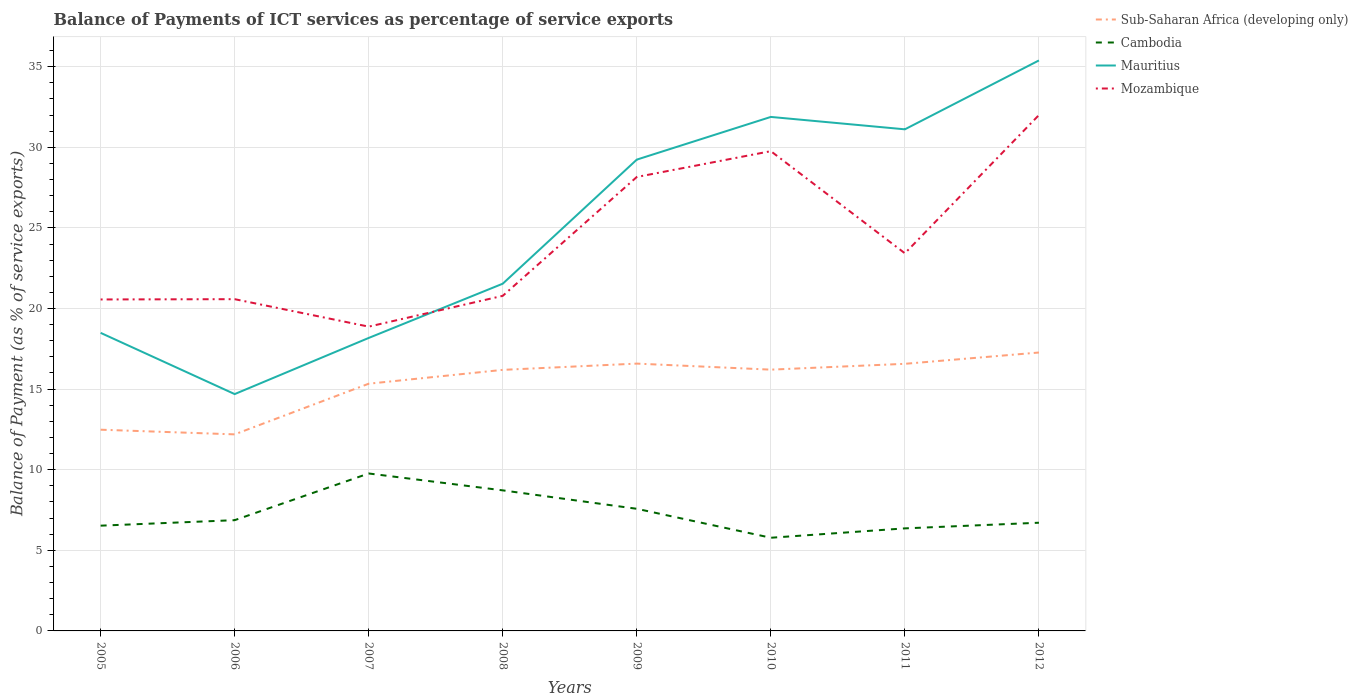How many different coloured lines are there?
Provide a succinct answer. 4. Across all years, what is the maximum balance of payments of ICT services in Mauritius?
Your answer should be compact. 14.69. In which year was the balance of payments of ICT services in Mauritius maximum?
Ensure brevity in your answer.  2006. What is the total balance of payments of ICT services in Cambodia in the graph?
Provide a short and direct response. -0.93. What is the difference between the highest and the second highest balance of payments of ICT services in Sub-Saharan Africa (developing only)?
Keep it short and to the point. 5.08. What is the difference between the highest and the lowest balance of payments of ICT services in Mauritius?
Your answer should be compact. 4. Is the balance of payments of ICT services in Cambodia strictly greater than the balance of payments of ICT services in Sub-Saharan Africa (developing only) over the years?
Your answer should be very brief. Yes. How many years are there in the graph?
Your response must be concise. 8. What is the difference between two consecutive major ticks on the Y-axis?
Your answer should be compact. 5. Are the values on the major ticks of Y-axis written in scientific E-notation?
Your answer should be very brief. No. Does the graph contain any zero values?
Your response must be concise. No. Does the graph contain grids?
Your response must be concise. Yes. How many legend labels are there?
Your response must be concise. 4. What is the title of the graph?
Provide a short and direct response. Balance of Payments of ICT services as percentage of service exports. What is the label or title of the Y-axis?
Give a very brief answer. Balance of Payment (as % of service exports). What is the Balance of Payment (as % of service exports) of Sub-Saharan Africa (developing only) in 2005?
Keep it short and to the point. 12.48. What is the Balance of Payment (as % of service exports) in Cambodia in 2005?
Keep it short and to the point. 6.53. What is the Balance of Payment (as % of service exports) in Mauritius in 2005?
Your answer should be compact. 18.49. What is the Balance of Payment (as % of service exports) in Mozambique in 2005?
Offer a terse response. 20.56. What is the Balance of Payment (as % of service exports) of Sub-Saharan Africa (developing only) in 2006?
Keep it short and to the point. 12.19. What is the Balance of Payment (as % of service exports) of Cambodia in 2006?
Give a very brief answer. 6.87. What is the Balance of Payment (as % of service exports) in Mauritius in 2006?
Ensure brevity in your answer.  14.69. What is the Balance of Payment (as % of service exports) in Mozambique in 2006?
Provide a succinct answer. 20.58. What is the Balance of Payment (as % of service exports) in Sub-Saharan Africa (developing only) in 2007?
Your answer should be very brief. 15.34. What is the Balance of Payment (as % of service exports) of Cambodia in 2007?
Ensure brevity in your answer.  9.77. What is the Balance of Payment (as % of service exports) of Mauritius in 2007?
Offer a very short reply. 18.17. What is the Balance of Payment (as % of service exports) in Mozambique in 2007?
Offer a very short reply. 18.88. What is the Balance of Payment (as % of service exports) in Sub-Saharan Africa (developing only) in 2008?
Give a very brief answer. 16.19. What is the Balance of Payment (as % of service exports) in Cambodia in 2008?
Ensure brevity in your answer.  8.72. What is the Balance of Payment (as % of service exports) in Mauritius in 2008?
Ensure brevity in your answer.  21.54. What is the Balance of Payment (as % of service exports) of Mozambique in 2008?
Offer a very short reply. 20.79. What is the Balance of Payment (as % of service exports) of Sub-Saharan Africa (developing only) in 2009?
Your response must be concise. 16.58. What is the Balance of Payment (as % of service exports) in Cambodia in 2009?
Give a very brief answer. 7.58. What is the Balance of Payment (as % of service exports) in Mauritius in 2009?
Ensure brevity in your answer.  29.24. What is the Balance of Payment (as % of service exports) of Mozambique in 2009?
Give a very brief answer. 28.16. What is the Balance of Payment (as % of service exports) in Sub-Saharan Africa (developing only) in 2010?
Your response must be concise. 16.21. What is the Balance of Payment (as % of service exports) of Cambodia in 2010?
Give a very brief answer. 5.78. What is the Balance of Payment (as % of service exports) in Mauritius in 2010?
Your answer should be compact. 31.88. What is the Balance of Payment (as % of service exports) in Mozambique in 2010?
Give a very brief answer. 29.76. What is the Balance of Payment (as % of service exports) of Sub-Saharan Africa (developing only) in 2011?
Offer a terse response. 16.57. What is the Balance of Payment (as % of service exports) of Cambodia in 2011?
Ensure brevity in your answer.  6.36. What is the Balance of Payment (as % of service exports) in Mauritius in 2011?
Make the answer very short. 31.12. What is the Balance of Payment (as % of service exports) of Mozambique in 2011?
Offer a very short reply. 23.43. What is the Balance of Payment (as % of service exports) in Sub-Saharan Africa (developing only) in 2012?
Ensure brevity in your answer.  17.27. What is the Balance of Payment (as % of service exports) in Cambodia in 2012?
Keep it short and to the point. 6.71. What is the Balance of Payment (as % of service exports) in Mauritius in 2012?
Keep it short and to the point. 35.39. What is the Balance of Payment (as % of service exports) in Mozambique in 2012?
Ensure brevity in your answer.  32. Across all years, what is the maximum Balance of Payment (as % of service exports) of Sub-Saharan Africa (developing only)?
Keep it short and to the point. 17.27. Across all years, what is the maximum Balance of Payment (as % of service exports) of Cambodia?
Give a very brief answer. 9.77. Across all years, what is the maximum Balance of Payment (as % of service exports) of Mauritius?
Offer a very short reply. 35.39. Across all years, what is the maximum Balance of Payment (as % of service exports) in Mozambique?
Give a very brief answer. 32. Across all years, what is the minimum Balance of Payment (as % of service exports) of Sub-Saharan Africa (developing only)?
Your answer should be very brief. 12.19. Across all years, what is the minimum Balance of Payment (as % of service exports) of Cambodia?
Your answer should be very brief. 5.78. Across all years, what is the minimum Balance of Payment (as % of service exports) in Mauritius?
Keep it short and to the point. 14.69. Across all years, what is the minimum Balance of Payment (as % of service exports) in Mozambique?
Offer a terse response. 18.88. What is the total Balance of Payment (as % of service exports) in Sub-Saharan Africa (developing only) in the graph?
Provide a short and direct response. 122.83. What is the total Balance of Payment (as % of service exports) of Cambodia in the graph?
Your answer should be compact. 58.31. What is the total Balance of Payment (as % of service exports) in Mauritius in the graph?
Ensure brevity in your answer.  200.52. What is the total Balance of Payment (as % of service exports) of Mozambique in the graph?
Your answer should be compact. 194.15. What is the difference between the Balance of Payment (as % of service exports) of Sub-Saharan Africa (developing only) in 2005 and that in 2006?
Ensure brevity in your answer.  0.29. What is the difference between the Balance of Payment (as % of service exports) of Cambodia in 2005 and that in 2006?
Give a very brief answer. -0.34. What is the difference between the Balance of Payment (as % of service exports) in Mauritius in 2005 and that in 2006?
Provide a succinct answer. 3.8. What is the difference between the Balance of Payment (as % of service exports) in Mozambique in 2005 and that in 2006?
Make the answer very short. -0.02. What is the difference between the Balance of Payment (as % of service exports) of Sub-Saharan Africa (developing only) in 2005 and that in 2007?
Give a very brief answer. -2.85. What is the difference between the Balance of Payment (as % of service exports) in Cambodia in 2005 and that in 2007?
Ensure brevity in your answer.  -3.24. What is the difference between the Balance of Payment (as % of service exports) in Mauritius in 2005 and that in 2007?
Offer a terse response. 0.32. What is the difference between the Balance of Payment (as % of service exports) of Mozambique in 2005 and that in 2007?
Your response must be concise. 1.69. What is the difference between the Balance of Payment (as % of service exports) in Sub-Saharan Africa (developing only) in 2005 and that in 2008?
Ensure brevity in your answer.  -3.71. What is the difference between the Balance of Payment (as % of service exports) of Cambodia in 2005 and that in 2008?
Your response must be concise. -2.19. What is the difference between the Balance of Payment (as % of service exports) in Mauritius in 2005 and that in 2008?
Give a very brief answer. -3.05. What is the difference between the Balance of Payment (as % of service exports) of Mozambique in 2005 and that in 2008?
Provide a short and direct response. -0.22. What is the difference between the Balance of Payment (as % of service exports) in Cambodia in 2005 and that in 2009?
Keep it short and to the point. -1.05. What is the difference between the Balance of Payment (as % of service exports) of Mauritius in 2005 and that in 2009?
Offer a very short reply. -10.75. What is the difference between the Balance of Payment (as % of service exports) in Mozambique in 2005 and that in 2009?
Provide a succinct answer. -7.6. What is the difference between the Balance of Payment (as % of service exports) in Sub-Saharan Africa (developing only) in 2005 and that in 2010?
Provide a succinct answer. -3.73. What is the difference between the Balance of Payment (as % of service exports) in Cambodia in 2005 and that in 2010?
Provide a short and direct response. 0.75. What is the difference between the Balance of Payment (as % of service exports) in Mauritius in 2005 and that in 2010?
Keep it short and to the point. -13.39. What is the difference between the Balance of Payment (as % of service exports) of Mozambique in 2005 and that in 2010?
Your answer should be very brief. -9.2. What is the difference between the Balance of Payment (as % of service exports) of Sub-Saharan Africa (developing only) in 2005 and that in 2011?
Make the answer very short. -4.09. What is the difference between the Balance of Payment (as % of service exports) in Cambodia in 2005 and that in 2011?
Provide a succinct answer. 0.17. What is the difference between the Balance of Payment (as % of service exports) in Mauritius in 2005 and that in 2011?
Keep it short and to the point. -12.63. What is the difference between the Balance of Payment (as % of service exports) of Mozambique in 2005 and that in 2011?
Ensure brevity in your answer.  -2.86. What is the difference between the Balance of Payment (as % of service exports) of Sub-Saharan Africa (developing only) in 2005 and that in 2012?
Your response must be concise. -4.79. What is the difference between the Balance of Payment (as % of service exports) of Cambodia in 2005 and that in 2012?
Your answer should be compact. -0.18. What is the difference between the Balance of Payment (as % of service exports) in Mauritius in 2005 and that in 2012?
Offer a very short reply. -16.9. What is the difference between the Balance of Payment (as % of service exports) in Mozambique in 2005 and that in 2012?
Provide a short and direct response. -11.44. What is the difference between the Balance of Payment (as % of service exports) of Sub-Saharan Africa (developing only) in 2006 and that in 2007?
Provide a succinct answer. -3.14. What is the difference between the Balance of Payment (as % of service exports) of Cambodia in 2006 and that in 2007?
Your response must be concise. -2.9. What is the difference between the Balance of Payment (as % of service exports) in Mauritius in 2006 and that in 2007?
Your answer should be very brief. -3.48. What is the difference between the Balance of Payment (as % of service exports) of Mozambique in 2006 and that in 2007?
Your answer should be compact. 1.7. What is the difference between the Balance of Payment (as % of service exports) of Sub-Saharan Africa (developing only) in 2006 and that in 2008?
Your answer should be compact. -4. What is the difference between the Balance of Payment (as % of service exports) of Cambodia in 2006 and that in 2008?
Keep it short and to the point. -1.85. What is the difference between the Balance of Payment (as % of service exports) in Mauritius in 2006 and that in 2008?
Your response must be concise. -6.85. What is the difference between the Balance of Payment (as % of service exports) of Mozambique in 2006 and that in 2008?
Your answer should be compact. -0.21. What is the difference between the Balance of Payment (as % of service exports) in Sub-Saharan Africa (developing only) in 2006 and that in 2009?
Give a very brief answer. -4.39. What is the difference between the Balance of Payment (as % of service exports) in Cambodia in 2006 and that in 2009?
Your answer should be very brief. -0.71. What is the difference between the Balance of Payment (as % of service exports) of Mauritius in 2006 and that in 2009?
Offer a very short reply. -14.54. What is the difference between the Balance of Payment (as % of service exports) of Mozambique in 2006 and that in 2009?
Your answer should be very brief. -7.58. What is the difference between the Balance of Payment (as % of service exports) of Sub-Saharan Africa (developing only) in 2006 and that in 2010?
Your response must be concise. -4.01. What is the difference between the Balance of Payment (as % of service exports) of Cambodia in 2006 and that in 2010?
Provide a succinct answer. 1.09. What is the difference between the Balance of Payment (as % of service exports) of Mauritius in 2006 and that in 2010?
Provide a short and direct response. -17.19. What is the difference between the Balance of Payment (as % of service exports) of Mozambique in 2006 and that in 2010?
Offer a very short reply. -9.18. What is the difference between the Balance of Payment (as % of service exports) of Sub-Saharan Africa (developing only) in 2006 and that in 2011?
Your answer should be very brief. -4.38. What is the difference between the Balance of Payment (as % of service exports) of Cambodia in 2006 and that in 2011?
Give a very brief answer. 0.51. What is the difference between the Balance of Payment (as % of service exports) in Mauritius in 2006 and that in 2011?
Keep it short and to the point. -16.42. What is the difference between the Balance of Payment (as % of service exports) in Mozambique in 2006 and that in 2011?
Your response must be concise. -2.85. What is the difference between the Balance of Payment (as % of service exports) in Sub-Saharan Africa (developing only) in 2006 and that in 2012?
Your answer should be very brief. -5.08. What is the difference between the Balance of Payment (as % of service exports) in Cambodia in 2006 and that in 2012?
Your response must be concise. 0.16. What is the difference between the Balance of Payment (as % of service exports) in Mauritius in 2006 and that in 2012?
Your response must be concise. -20.7. What is the difference between the Balance of Payment (as % of service exports) in Mozambique in 2006 and that in 2012?
Your answer should be compact. -11.42. What is the difference between the Balance of Payment (as % of service exports) of Sub-Saharan Africa (developing only) in 2007 and that in 2008?
Keep it short and to the point. -0.86. What is the difference between the Balance of Payment (as % of service exports) of Cambodia in 2007 and that in 2008?
Provide a short and direct response. 1.05. What is the difference between the Balance of Payment (as % of service exports) of Mauritius in 2007 and that in 2008?
Your answer should be compact. -3.37. What is the difference between the Balance of Payment (as % of service exports) of Mozambique in 2007 and that in 2008?
Give a very brief answer. -1.91. What is the difference between the Balance of Payment (as % of service exports) of Sub-Saharan Africa (developing only) in 2007 and that in 2009?
Your answer should be very brief. -1.25. What is the difference between the Balance of Payment (as % of service exports) in Cambodia in 2007 and that in 2009?
Your response must be concise. 2.19. What is the difference between the Balance of Payment (as % of service exports) of Mauritius in 2007 and that in 2009?
Keep it short and to the point. -11.06. What is the difference between the Balance of Payment (as % of service exports) of Mozambique in 2007 and that in 2009?
Your answer should be compact. -9.28. What is the difference between the Balance of Payment (as % of service exports) in Sub-Saharan Africa (developing only) in 2007 and that in 2010?
Offer a very short reply. -0.87. What is the difference between the Balance of Payment (as % of service exports) of Cambodia in 2007 and that in 2010?
Give a very brief answer. 3.99. What is the difference between the Balance of Payment (as % of service exports) of Mauritius in 2007 and that in 2010?
Make the answer very short. -13.71. What is the difference between the Balance of Payment (as % of service exports) in Mozambique in 2007 and that in 2010?
Provide a succinct answer. -10.88. What is the difference between the Balance of Payment (as % of service exports) in Sub-Saharan Africa (developing only) in 2007 and that in 2011?
Provide a short and direct response. -1.23. What is the difference between the Balance of Payment (as % of service exports) in Cambodia in 2007 and that in 2011?
Your answer should be very brief. 3.41. What is the difference between the Balance of Payment (as % of service exports) of Mauritius in 2007 and that in 2011?
Offer a very short reply. -12.94. What is the difference between the Balance of Payment (as % of service exports) in Mozambique in 2007 and that in 2011?
Keep it short and to the point. -4.55. What is the difference between the Balance of Payment (as % of service exports) of Sub-Saharan Africa (developing only) in 2007 and that in 2012?
Your response must be concise. -1.93. What is the difference between the Balance of Payment (as % of service exports) in Cambodia in 2007 and that in 2012?
Your answer should be compact. 3.06. What is the difference between the Balance of Payment (as % of service exports) in Mauritius in 2007 and that in 2012?
Give a very brief answer. -17.21. What is the difference between the Balance of Payment (as % of service exports) in Mozambique in 2007 and that in 2012?
Your answer should be compact. -13.13. What is the difference between the Balance of Payment (as % of service exports) of Sub-Saharan Africa (developing only) in 2008 and that in 2009?
Give a very brief answer. -0.39. What is the difference between the Balance of Payment (as % of service exports) of Cambodia in 2008 and that in 2009?
Ensure brevity in your answer.  1.14. What is the difference between the Balance of Payment (as % of service exports) of Mauritius in 2008 and that in 2009?
Make the answer very short. -7.7. What is the difference between the Balance of Payment (as % of service exports) of Mozambique in 2008 and that in 2009?
Make the answer very short. -7.37. What is the difference between the Balance of Payment (as % of service exports) of Sub-Saharan Africa (developing only) in 2008 and that in 2010?
Ensure brevity in your answer.  -0.01. What is the difference between the Balance of Payment (as % of service exports) of Cambodia in 2008 and that in 2010?
Keep it short and to the point. 2.94. What is the difference between the Balance of Payment (as % of service exports) of Mauritius in 2008 and that in 2010?
Offer a terse response. -10.34. What is the difference between the Balance of Payment (as % of service exports) in Mozambique in 2008 and that in 2010?
Make the answer very short. -8.97. What is the difference between the Balance of Payment (as % of service exports) in Sub-Saharan Africa (developing only) in 2008 and that in 2011?
Your answer should be compact. -0.38. What is the difference between the Balance of Payment (as % of service exports) in Cambodia in 2008 and that in 2011?
Offer a very short reply. 2.36. What is the difference between the Balance of Payment (as % of service exports) of Mauritius in 2008 and that in 2011?
Ensure brevity in your answer.  -9.58. What is the difference between the Balance of Payment (as % of service exports) in Mozambique in 2008 and that in 2011?
Keep it short and to the point. -2.64. What is the difference between the Balance of Payment (as % of service exports) of Sub-Saharan Africa (developing only) in 2008 and that in 2012?
Make the answer very short. -1.08. What is the difference between the Balance of Payment (as % of service exports) of Cambodia in 2008 and that in 2012?
Your answer should be very brief. 2.01. What is the difference between the Balance of Payment (as % of service exports) in Mauritius in 2008 and that in 2012?
Make the answer very short. -13.85. What is the difference between the Balance of Payment (as % of service exports) of Mozambique in 2008 and that in 2012?
Offer a very short reply. -11.21. What is the difference between the Balance of Payment (as % of service exports) of Cambodia in 2009 and that in 2010?
Offer a terse response. 1.8. What is the difference between the Balance of Payment (as % of service exports) of Mauritius in 2009 and that in 2010?
Ensure brevity in your answer.  -2.65. What is the difference between the Balance of Payment (as % of service exports) in Mozambique in 2009 and that in 2010?
Keep it short and to the point. -1.6. What is the difference between the Balance of Payment (as % of service exports) of Sub-Saharan Africa (developing only) in 2009 and that in 2011?
Provide a short and direct response. 0.01. What is the difference between the Balance of Payment (as % of service exports) of Cambodia in 2009 and that in 2011?
Your response must be concise. 1.21. What is the difference between the Balance of Payment (as % of service exports) in Mauritius in 2009 and that in 2011?
Provide a short and direct response. -1.88. What is the difference between the Balance of Payment (as % of service exports) of Mozambique in 2009 and that in 2011?
Provide a short and direct response. 4.73. What is the difference between the Balance of Payment (as % of service exports) in Sub-Saharan Africa (developing only) in 2009 and that in 2012?
Offer a terse response. -0.69. What is the difference between the Balance of Payment (as % of service exports) of Cambodia in 2009 and that in 2012?
Offer a terse response. 0.86. What is the difference between the Balance of Payment (as % of service exports) of Mauritius in 2009 and that in 2012?
Make the answer very short. -6.15. What is the difference between the Balance of Payment (as % of service exports) of Mozambique in 2009 and that in 2012?
Provide a short and direct response. -3.84. What is the difference between the Balance of Payment (as % of service exports) of Sub-Saharan Africa (developing only) in 2010 and that in 2011?
Provide a succinct answer. -0.36. What is the difference between the Balance of Payment (as % of service exports) of Cambodia in 2010 and that in 2011?
Provide a succinct answer. -0.58. What is the difference between the Balance of Payment (as % of service exports) in Mauritius in 2010 and that in 2011?
Provide a succinct answer. 0.77. What is the difference between the Balance of Payment (as % of service exports) in Mozambique in 2010 and that in 2011?
Make the answer very short. 6.34. What is the difference between the Balance of Payment (as % of service exports) of Sub-Saharan Africa (developing only) in 2010 and that in 2012?
Ensure brevity in your answer.  -1.06. What is the difference between the Balance of Payment (as % of service exports) of Cambodia in 2010 and that in 2012?
Your response must be concise. -0.93. What is the difference between the Balance of Payment (as % of service exports) in Mauritius in 2010 and that in 2012?
Your answer should be very brief. -3.5. What is the difference between the Balance of Payment (as % of service exports) in Mozambique in 2010 and that in 2012?
Your answer should be very brief. -2.24. What is the difference between the Balance of Payment (as % of service exports) of Sub-Saharan Africa (developing only) in 2011 and that in 2012?
Offer a terse response. -0.7. What is the difference between the Balance of Payment (as % of service exports) in Cambodia in 2011 and that in 2012?
Provide a short and direct response. -0.35. What is the difference between the Balance of Payment (as % of service exports) of Mauritius in 2011 and that in 2012?
Give a very brief answer. -4.27. What is the difference between the Balance of Payment (as % of service exports) in Mozambique in 2011 and that in 2012?
Your answer should be very brief. -8.58. What is the difference between the Balance of Payment (as % of service exports) of Sub-Saharan Africa (developing only) in 2005 and the Balance of Payment (as % of service exports) of Cambodia in 2006?
Give a very brief answer. 5.61. What is the difference between the Balance of Payment (as % of service exports) in Sub-Saharan Africa (developing only) in 2005 and the Balance of Payment (as % of service exports) in Mauritius in 2006?
Keep it short and to the point. -2.21. What is the difference between the Balance of Payment (as % of service exports) of Sub-Saharan Africa (developing only) in 2005 and the Balance of Payment (as % of service exports) of Mozambique in 2006?
Keep it short and to the point. -8.1. What is the difference between the Balance of Payment (as % of service exports) in Cambodia in 2005 and the Balance of Payment (as % of service exports) in Mauritius in 2006?
Provide a short and direct response. -8.16. What is the difference between the Balance of Payment (as % of service exports) of Cambodia in 2005 and the Balance of Payment (as % of service exports) of Mozambique in 2006?
Keep it short and to the point. -14.05. What is the difference between the Balance of Payment (as % of service exports) of Mauritius in 2005 and the Balance of Payment (as % of service exports) of Mozambique in 2006?
Offer a very short reply. -2.09. What is the difference between the Balance of Payment (as % of service exports) in Sub-Saharan Africa (developing only) in 2005 and the Balance of Payment (as % of service exports) in Cambodia in 2007?
Your answer should be very brief. 2.72. What is the difference between the Balance of Payment (as % of service exports) in Sub-Saharan Africa (developing only) in 2005 and the Balance of Payment (as % of service exports) in Mauritius in 2007?
Your response must be concise. -5.69. What is the difference between the Balance of Payment (as % of service exports) of Sub-Saharan Africa (developing only) in 2005 and the Balance of Payment (as % of service exports) of Mozambique in 2007?
Your response must be concise. -6.39. What is the difference between the Balance of Payment (as % of service exports) of Cambodia in 2005 and the Balance of Payment (as % of service exports) of Mauritius in 2007?
Give a very brief answer. -11.64. What is the difference between the Balance of Payment (as % of service exports) of Cambodia in 2005 and the Balance of Payment (as % of service exports) of Mozambique in 2007?
Your response must be concise. -12.35. What is the difference between the Balance of Payment (as % of service exports) in Mauritius in 2005 and the Balance of Payment (as % of service exports) in Mozambique in 2007?
Your answer should be compact. -0.39. What is the difference between the Balance of Payment (as % of service exports) in Sub-Saharan Africa (developing only) in 2005 and the Balance of Payment (as % of service exports) in Cambodia in 2008?
Your answer should be compact. 3.76. What is the difference between the Balance of Payment (as % of service exports) of Sub-Saharan Africa (developing only) in 2005 and the Balance of Payment (as % of service exports) of Mauritius in 2008?
Ensure brevity in your answer.  -9.06. What is the difference between the Balance of Payment (as % of service exports) of Sub-Saharan Africa (developing only) in 2005 and the Balance of Payment (as % of service exports) of Mozambique in 2008?
Offer a very short reply. -8.3. What is the difference between the Balance of Payment (as % of service exports) in Cambodia in 2005 and the Balance of Payment (as % of service exports) in Mauritius in 2008?
Give a very brief answer. -15.01. What is the difference between the Balance of Payment (as % of service exports) of Cambodia in 2005 and the Balance of Payment (as % of service exports) of Mozambique in 2008?
Provide a short and direct response. -14.26. What is the difference between the Balance of Payment (as % of service exports) in Mauritius in 2005 and the Balance of Payment (as % of service exports) in Mozambique in 2008?
Your response must be concise. -2.3. What is the difference between the Balance of Payment (as % of service exports) of Sub-Saharan Africa (developing only) in 2005 and the Balance of Payment (as % of service exports) of Cambodia in 2009?
Ensure brevity in your answer.  4.91. What is the difference between the Balance of Payment (as % of service exports) in Sub-Saharan Africa (developing only) in 2005 and the Balance of Payment (as % of service exports) in Mauritius in 2009?
Offer a very short reply. -16.75. What is the difference between the Balance of Payment (as % of service exports) of Sub-Saharan Africa (developing only) in 2005 and the Balance of Payment (as % of service exports) of Mozambique in 2009?
Ensure brevity in your answer.  -15.68. What is the difference between the Balance of Payment (as % of service exports) in Cambodia in 2005 and the Balance of Payment (as % of service exports) in Mauritius in 2009?
Ensure brevity in your answer.  -22.71. What is the difference between the Balance of Payment (as % of service exports) in Cambodia in 2005 and the Balance of Payment (as % of service exports) in Mozambique in 2009?
Your response must be concise. -21.63. What is the difference between the Balance of Payment (as % of service exports) in Mauritius in 2005 and the Balance of Payment (as % of service exports) in Mozambique in 2009?
Your answer should be very brief. -9.67. What is the difference between the Balance of Payment (as % of service exports) of Sub-Saharan Africa (developing only) in 2005 and the Balance of Payment (as % of service exports) of Cambodia in 2010?
Your answer should be very brief. 6.7. What is the difference between the Balance of Payment (as % of service exports) of Sub-Saharan Africa (developing only) in 2005 and the Balance of Payment (as % of service exports) of Mauritius in 2010?
Offer a very short reply. -19.4. What is the difference between the Balance of Payment (as % of service exports) in Sub-Saharan Africa (developing only) in 2005 and the Balance of Payment (as % of service exports) in Mozambique in 2010?
Offer a very short reply. -17.28. What is the difference between the Balance of Payment (as % of service exports) of Cambodia in 2005 and the Balance of Payment (as % of service exports) of Mauritius in 2010?
Your answer should be compact. -25.36. What is the difference between the Balance of Payment (as % of service exports) in Cambodia in 2005 and the Balance of Payment (as % of service exports) in Mozambique in 2010?
Give a very brief answer. -23.23. What is the difference between the Balance of Payment (as % of service exports) of Mauritius in 2005 and the Balance of Payment (as % of service exports) of Mozambique in 2010?
Make the answer very short. -11.27. What is the difference between the Balance of Payment (as % of service exports) of Sub-Saharan Africa (developing only) in 2005 and the Balance of Payment (as % of service exports) of Cambodia in 2011?
Offer a terse response. 6.12. What is the difference between the Balance of Payment (as % of service exports) of Sub-Saharan Africa (developing only) in 2005 and the Balance of Payment (as % of service exports) of Mauritius in 2011?
Your answer should be very brief. -18.63. What is the difference between the Balance of Payment (as % of service exports) in Sub-Saharan Africa (developing only) in 2005 and the Balance of Payment (as % of service exports) in Mozambique in 2011?
Keep it short and to the point. -10.94. What is the difference between the Balance of Payment (as % of service exports) in Cambodia in 2005 and the Balance of Payment (as % of service exports) in Mauritius in 2011?
Your response must be concise. -24.59. What is the difference between the Balance of Payment (as % of service exports) of Cambodia in 2005 and the Balance of Payment (as % of service exports) of Mozambique in 2011?
Your response must be concise. -16.9. What is the difference between the Balance of Payment (as % of service exports) of Mauritius in 2005 and the Balance of Payment (as % of service exports) of Mozambique in 2011?
Keep it short and to the point. -4.94. What is the difference between the Balance of Payment (as % of service exports) of Sub-Saharan Africa (developing only) in 2005 and the Balance of Payment (as % of service exports) of Cambodia in 2012?
Provide a succinct answer. 5.77. What is the difference between the Balance of Payment (as % of service exports) of Sub-Saharan Africa (developing only) in 2005 and the Balance of Payment (as % of service exports) of Mauritius in 2012?
Make the answer very short. -22.91. What is the difference between the Balance of Payment (as % of service exports) of Sub-Saharan Africa (developing only) in 2005 and the Balance of Payment (as % of service exports) of Mozambique in 2012?
Make the answer very short. -19.52. What is the difference between the Balance of Payment (as % of service exports) of Cambodia in 2005 and the Balance of Payment (as % of service exports) of Mauritius in 2012?
Make the answer very short. -28.86. What is the difference between the Balance of Payment (as % of service exports) in Cambodia in 2005 and the Balance of Payment (as % of service exports) in Mozambique in 2012?
Provide a succinct answer. -25.47. What is the difference between the Balance of Payment (as % of service exports) in Mauritius in 2005 and the Balance of Payment (as % of service exports) in Mozambique in 2012?
Offer a terse response. -13.51. What is the difference between the Balance of Payment (as % of service exports) in Sub-Saharan Africa (developing only) in 2006 and the Balance of Payment (as % of service exports) in Cambodia in 2007?
Your answer should be very brief. 2.43. What is the difference between the Balance of Payment (as % of service exports) of Sub-Saharan Africa (developing only) in 2006 and the Balance of Payment (as % of service exports) of Mauritius in 2007?
Your answer should be compact. -5.98. What is the difference between the Balance of Payment (as % of service exports) in Sub-Saharan Africa (developing only) in 2006 and the Balance of Payment (as % of service exports) in Mozambique in 2007?
Provide a short and direct response. -6.68. What is the difference between the Balance of Payment (as % of service exports) of Cambodia in 2006 and the Balance of Payment (as % of service exports) of Mauritius in 2007?
Provide a short and direct response. -11.3. What is the difference between the Balance of Payment (as % of service exports) of Cambodia in 2006 and the Balance of Payment (as % of service exports) of Mozambique in 2007?
Your answer should be very brief. -12.01. What is the difference between the Balance of Payment (as % of service exports) of Mauritius in 2006 and the Balance of Payment (as % of service exports) of Mozambique in 2007?
Your answer should be very brief. -4.18. What is the difference between the Balance of Payment (as % of service exports) of Sub-Saharan Africa (developing only) in 2006 and the Balance of Payment (as % of service exports) of Cambodia in 2008?
Provide a succinct answer. 3.47. What is the difference between the Balance of Payment (as % of service exports) of Sub-Saharan Africa (developing only) in 2006 and the Balance of Payment (as % of service exports) of Mauritius in 2008?
Keep it short and to the point. -9.35. What is the difference between the Balance of Payment (as % of service exports) in Sub-Saharan Africa (developing only) in 2006 and the Balance of Payment (as % of service exports) in Mozambique in 2008?
Provide a short and direct response. -8.59. What is the difference between the Balance of Payment (as % of service exports) in Cambodia in 2006 and the Balance of Payment (as % of service exports) in Mauritius in 2008?
Offer a very short reply. -14.67. What is the difference between the Balance of Payment (as % of service exports) in Cambodia in 2006 and the Balance of Payment (as % of service exports) in Mozambique in 2008?
Provide a succinct answer. -13.92. What is the difference between the Balance of Payment (as % of service exports) of Mauritius in 2006 and the Balance of Payment (as % of service exports) of Mozambique in 2008?
Ensure brevity in your answer.  -6.1. What is the difference between the Balance of Payment (as % of service exports) of Sub-Saharan Africa (developing only) in 2006 and the Balance of Payment (as % of service exports) of Cambodia in 2009?
Make the answer very short. 4.62. What is the difference between the Balance of Payment (as % of service exports) of Sub-Saharan Africa (developing only) in 2006 and the Balance of Payment (as % of service exports) of Mauritius in 2009?
Ensure brevity in your answer.  -17.04. What is the difference between the Balance of Payment (as % of service exports) in Sub-Saharan Africa (developing only) in 2006 and the Balance of Payment (as % of service exports) in Mozambique in 2009?
Your answer should be compact. -15.97. What is the difference between the Balance of Payment (as % of service exports) in Cambodia in 2006 and the Balance of Payment (as % of service exports) in Mauritius in 2009?
Your answer should be very brief. -22.37. What is the difference between the Balance of Payment (as % of service exports) of Cambodia in 2006 and the Balance of Payment (as % of service exports) of Mozambique in 2009?
Provide a short and direct response. -21.29. What is the difference between the Balance of Payment (as % of service exports) of Mauritius in 2006 and the Balance of Payment (as % of service exports) of Mozambique in 2009?
Your answer should be very brief. -13.47. What is the difference between the Balance of Payment (as % of service exports) of Sub-Saharan Africa (developing only) in 2006 and the Balance of Payment (as % of service exports) of Cambodia in 2010?
Give a very brief answer. 6.41. What is the difference between the Balance of Payment (as % of service exports) of Sub-Saharan Africa (developing only) in 2006 and the Balance of Payment (as % of service exports) of Mauritius in 2010?
Your response must be concise. -19.69. What is the difference between the Balance of Payment (as % of service exports) of Sub-Saharan Africa (developing only) in 2006 and the Balance of Payment (as % of service exports) of Mozambique in 2010?
Make the answer very short. -17.57. What is the difference between the Balance of Payment (as % of service exports) of Cambodia in 2006 and the Balance of Payment (as % of service exports) of Mauritius in 2010?
Give a very brief answer. -25.01. What is the difference between the Balance of Payment (as % of service exports) in Cambodia in 2006 and the Balance of Payment (as % of service exports) in Mozambique in 2010?
Provide a short and direct response. -22.89. What is the difference between the Balance of Payment (as % of service exports) of Mauritius in 2006 and the Balance of Payment (as % of service exports) of Mozambique in 2010?
Provide a succinct answer. -15.07. What is the difference between the Balance of Payment (as % of service exports) of Sub-Saharan Africa (developing only) in 2006 and the Balance of Payment (as % of service exports) of Cambodia in 2011?
Your response must be concise. 5.83. What is the difference between the Balance of Payment (as % of service exports) in Sub-Saharan Africa (developing only) in 2006 and the Balance of Payment (as % of service exports) in Mauritius in 2011?
Give a very brief answer. -18.92. What is the difference between the Balance of Payment (as % of service exports) in Sub-Saharan Africa (developing only) in 2006 and the Balance of Payment (as % of service exports) in Mozambique in 2011?
Ensure brevity in your answer.  -11.23. What is the difference between the Balance of Payment (as % of service exports) in Cambodia in 2006 and the Balance of Payment (as % of service exports) in Mauritius in 2011?
Your response must be concise. -24.25. What is the difference between the Balance of Payment (as % of service exports) of Cambodia in 2006 and the Balance of Payment (as % of service exports) of Mozambique in 2011?
Give a very brief answer. -16.56. What is the difference between the Balance of Payment (as % of service exports) of Mauritius in 2006 and the Balance of Payment (as % of service exports) of Mozambique in 2011?
Ensure brevity in your answer.  -8.73. What is the difference between the Balance of Payment (as % of service exports) in Sub-Saharan Africa (developing only) in 2006 and the Balance of Payment (as % of service exports) in Cambodia in 2012?
Your answer should be very brief. 5.48. What is the difference between the Balance of Payment (as % of service exports) of Sub-Saharan Africa (developing only) in 2006 and the Balance of Payment (as % of service exports) of Mauritius in 2012?
Give a very brief answer. -23.2. What is the difference between the Balance of Payment (as % of service exports) in Sub-Saharan Africa (developing only) in 2006 and the Balance of Payment (as % of service exports) in Mozambique in 2012?
Offer a terse response. -19.81. What is the difference between the Balance of Payment (as % of service exports) in Cambodia in 2006 and the Balance of Payment (as % of service exports) in Mauritius in 2012?
Your answer should be very brief. -28.52. What is the difference between the Balance of Payment (as % of service exports) in Cambodia in 2006 and the Balance of Payment (as % of service exports) in Mozambique in 2012?
Your answer should be very brief. -25.13. What is the difference between the Balance of Payment (as % of service exports) in Mauritius in 2006 and the Balance of Payment (as % of service exports) in Mozambique in 2012?
Give a very brief answer. -17.31. What is the difference between the Balance of Payment (as % of service exports) in Sub-Saharan Africa (developing only) in 2007 and the Balance of Payment (as % of service exports) in Cambodia in 2008?
Your answer should be compact. 6.62. What is the difference between the Balance of Payment (as % of service exports) of Sub-Saharan Africa (developing only) in 2007 and the Balance of Payment (as % of service exports) of Mauritius in 2008?
Your answer should be compact. -6.2. What is the difference between the Balance of Payment (as % of service exports) of Sub-Saharan Africa (developing only) in 2007 and the Balance of Payment (as % of service exports) of Mozambique in 2008?
Provide a succinct answer. -5.45. What is the difference between the Balance of Payment (as % of service exports) of Cambodia in 2007 and the Balance of Payment (as % of service exports) of Mauritius in 2008?
Give a very brief answer. -11.77. What is the difference between the Balance of Payment (as % of service exports) of Cambodia in 2007 and the Balance of Payment (as % of service exports) of Mozambique in 2008?
Offer a very short reply. -11.02. What is the difference between the Balance of Payment (as % of service exports) of Mauritius in 2007 and the Balance of Payment (as % of service exports) of Mozambique in 2008?
Your response must be concise. -2.61. What is the difference between the Balance of Payment (as % of service exports) in Sub-Saharan Africa (developing only) in 2007 and the Balance of Payment (as % of service exports) in Cambodia in 2009?
Offer a terse response. 7.76. What is the difference between the Balance of Payment (as % of service exports) in Sub-Saharan Africa (developing only) in 2007 and the Balance of Payment (as % of service exports) in Mauritius in 2009?
Keep it short and to the point. -13.9. What is the difference between the Balance of Payment (as % of service exports) in Sub-Saharan Africa (developing only) in 2007 and the Balance of Payment (as % of service exports) in Mozambique in 2009?
Your answer should be very brief. -12.82. What is the difference between the Balance of Payment (as % of service exports) in Cambodia in 2007 and the Balance of Payment (as % of service exports) in Mauritius in 2009?
Offer a very short reply. -19.47. What is the difference between the Balance of Payment (as % of service exports) in Cambodia in 2007 and the Balance of Payment (as % of service exports) in Mozambique in 2009?
Make the answer very short. -18.39. What is the difference between the Balance of Payment (as % of service exports) of Mauritius in 2007 and the Balance of Payment (as % of service exports) of Mozambique in 2009?
Your answer should be very brief. -9.99. What is the difference between the Balance of Payment (as % of service exports) in Sub-Saharan Africa (developing only) in 2007 and the Balance of Payment (as % of service exports) in Cambodia in 2010?
Keep it short and to the point. 9.56. What is the difference between the Balance of Payment (as % of service exports) in Sub-Saharan Africa (developing only) in 2007 and the Balance of Payment (as % of service exports) in Mauritius in 2010?
Keep it short and to the point. -16.55. What is the difference between the Balance of Payment (as % of service exports) of Sub-Saharan Africa (developing only) in 2007 and the Balance of Payment (as % of service exports) of Mozambique in 2010?
Give a very brief answer. -14.42. What is the difference between the Balance of Payment (as % of service exports) of Cambodia in 2007 and the Balance of Payment (as % of service exports) of Mauritius in 2010?
Ensure brevity in your answer.  -22.12. What is the difference between the Balance of Payment (as % of service exports) in Cambodia in 2007 and the Balance of Payment (as % of service exports) in Mozambique in 2010?
Ensure brevity in your answer.  -19.99. What is the difference between the Balance of Payment (as % of service exports) of Mauritius in 2007 and the Balance of Payment (as % of service exports) of Mozambique in 2010?
Your answer should be very brief. -11.59. What is the difference between the Balance of Payment (as % of service exports) of Sub-Saharan Africa (developing only) in 2007 and the Balance of Payment (as % of service exports) of Cambodia in 2011?
Provide a succinct answer. 8.97. What is the difference between the Balance of Payment (as % of service exports) of Sub-Saharan Africa (developing only) in 2007 and the Balance of Payment (as % of service exports) of Mauritius in 2011?
Your answer should be very brief. -15.78. What is the difference between the Balance of Payment (as % of service exports) of Sub-Saharan Africa (developing only) in 2007 and the Balance of Payment (as % of service exports) of Mozambique in 2011?
Make the answer very short. -8.09. What is the difference between the Balance of Payment (as % of service exports) of Cambodia in 2007 and the Balance of Payment (as % of service exports) of Mauritius in 2011?
Give a very brief answer. -21.35. What is the difference between the Balance of Payment (as % of service exports) in Cambodia in 2007 and the Balance of Payment (as % of service exports) in Mozambique in 2011?
Your answer should be very brief. -13.66. What is the difference between the Balance of Payment (as % of service exports) in Mauritius in 2007 and the Balance of Payment (as % of service exports) in Mozambique in 2011?
Your response must be concise. -5.25. What is the difference between the Balance of Payment (as % of service exports) of Sub-Saharan Africa (developing only) in 2007 and the Balance of Payment (as % of service exports) of Cambodia in 2012?
Offer a very short reply. 8.62. What is the difference between the Balance of Payment (as % of service exports) of Sub-Saharan Africa (developing only) in 2007 and the Balance of Payment (as % of service exports) of Mauritius in 2012?
Provide a short and direct response. -20.05. What is the difference between the Balance of Payment (as % of service exports) of Sub-Saharan Africa (developing only) in 2007 and the Balance of Payment (as % of service exports) of Mozambique in 2012?
Offer a terse response. -16.67. What is the difference between the Balance of Payment (as % of service exports) in Cambodia in 2007 and the Balance of Payment (as % of service exports) in Mauritius in 2012?
Offer a very short reply. -25.62. What is the difference between the Balance of Payment (as % of service exports) in Cambodia in 2007 and the Balance of Payment (as % of service exports) in Mozambique in 2012?
Provide a short and direct response. -22.23. What is the difference between the Balance of Payment (as % of service exports) in Mauritius in 2007 and the Balance of Payment (as % of service exports) in Mozambique in 2012?
Provide a short and direct response. -13.83. What is the difference between the Balance of Payment (as % of service exports) in Sub-Saharan Africa (developing only) in 2008 and the Balance of Payment (as % of service exports) in Cambodia in 2009?
Provide a succinct answer. 8.62. What is the difference between the Balance of Payment (as % of service exports) in Sub-Saharan Africa (developing only) in 2008 and the Balance of Payment (as % of service exports) in Mauritius in 2009?
Your response must be concise. -13.04. What is the difference between the Balance of Payment (as % of service exports) of Sub-Saharan Africa (developing only) in 2008 and the Balance of Payment (as % of service exports) of Mozambique in 2009?
Provide a succinct answer. -11.97. What is the difference between the Balance of Payment (as % of service exports) in Cambodia in 2008 and the Balance of Payment (as % of service exports) in Mauritius in 2009?
Your response must be concise. -20.52. What is the difference between the Balance of Payment (as % of service exports) in Cambodia in 2008 and the Balance of Payment (as % of service exports) in Mozambique in 2009?
Provide a short and direct response. -19.44. What is the difference between the Balance of Payment (as % of service exports) of Mauritius in 2008 and the Balance of Payment (as % of service exports) of Mozambique in 2009?
Offer a very short reply. -6.62. What is the difference between the Balance of Payment (as % of service exports) in Sub-Saharan Africa (developing only) in 2008 and the Balance of Payment (as % of service exports) in Cambodia in 2010?
Offer a terse response. 10.41. What is the difference between the Balance of Payment (as % of service exports) in Sub-Saharan Africa (developing only) in 2008 and the Balance of Payment (as % of service exports) in Mauritius in 2010?
Offer a very short reply. -15.69. What is the difference between the Balance of Payment (as % of service exports) in Sub-Saharan Africa (developing only) in 2008 and the Balance of Payment (as % of service exports) in Mozambique in 2010?
Offer a very short reply. -13.57. What is the difference between the Balance of Payment (as % of service exports) of Cambodia in 2008 and the Balance of Payment (as % of service exports) of Mauritius in 2010?
Your response must be concise. -23.17. What is the difference between the Balance of Payment (as % of service exports) in Cambodia in 2008 and the Balance of Payment (as % of service exports) in Mozambique in 2010?
Keep it short and to the point. -21.04. What is the difference between the Balance of Payment (as % of service exports) of Mauritius in 2008 and the Balance of Payment (as % of service exports) of Mozambique in 2010?
Make the answer very short. -8.22. What is the difference between the Balance of Payment (as % of service exports) of Sub-Saharan Africa (developing only) in 2008 and the Balance of Payment (as % of service exports) of Cambodia in 2011?
Your answer should be compact. 9.83. What is the difference between the Balance of Payment (as % of service exports) in Sub-Saharan Africa (developing only) in 2008 and the Balance of Payment (as % of service exports) in Mauritius in 2011?
Your answer should be compact. -14.92. What is the difference between the Balance of Payment (as % of service exports) in Sub-Saharan Africa (developing only) in 2008 and the Balance of Payment (as % of service exports) in Mozambique in 2011?
Give a very brief answer. -7.23. What is the difference between the Balance of Payment (as % of service exports) in Cambodia in 2008 and the Balance of Payment (as % of service exports) in Mauritius in 2011?
Offer a terse response. -22.4. What is the difference between the Balance of Payment (as % of service exports) of Cambodia in 2008 and the Balance of Payment (as % of service exports) of Mozambique in 2011?
Provide a short and direct response. -14.71. What is the difference between the Balance of Payment (as % of service exports) in Mauritius in 2008 and the Balance of Payment (as % of service exports) in Mozambique in 2011?
Provide a short and direct response. -1.89. What is the difference between the Balance of Payment (as % of service exports) in Sub-Saharan Africa (developing only) in 2008 and the Balance of Payment (as % of service exports) in Cambodia in 2012?
Give a very brief answer. 9.48. What is the difference between the Balance of Payment (as % of service exports) of Sub-Saharan Africa (developing only) in 2008 and the Balance of Payment (as % of service exports) of Mauritius in 2012?
Ensure brevity in your answer.  -19.19. What is the difference between the Balance of Payment (as % of service exports) of Sub-Saharan Africa (developing only) in 2008 and the Balance of Payment (as % of service exports) of Mozambique in 2012?
Provide a succinct answer. -15.81. What is the difference between the Balance of Payment (as % of service exports) of Cambodia in 2008 and the Balance of Payment (as % of service exports) of Mauritius in 2012?
Your answer should be very brief. -26.67. What is the difference between the Balance of Payment (as % of service exports) in Cambodia in 2008 and the Balance of Payment (as % of service exports) in Mozambique in 2012?
Offer a very short reply. -23.28. What is the difference between the Balance of Payment (as % of service exports) in Mauritius in 2008 and the Balance of Payment (as % of service exports) in Mozambique in 2012?
Provide a short and direct response. -10.46. What is the difference between the Balance of Payment (as % of service exports) in Sub-Saharan Africa (developing only) in 2009 and the Balance of Payment (as % of service exports) in Cambodia in 2010?
Give a very brief answer. 10.8. What is the difference between the Balance of Payment (as % of service exports) of Sub-Saharan Africa (developing only) in 2009 and the Balance of Payment (as % of service exports) of Mauritius in 2010?
Give a very brief answer. -15.3. What is the difference between the Balance of Payment (as % of service exports) in Sub-Saharan Africa (developing only) in 2009 and the Balance of Payment (as % of service exports) in Mozambique in 2010?
Offer a very short reply. -13.18. What is the difference between the Balance of Payment (as % of service exports) of Cambodia in 2009 and the Balance of Payment (as % of service exports) of Mauritius in 2010?
Provide a short and direct response. -24.31. What is the difference between the Balance of Payment (as % of service exports) in Cambodia in 2009 and the Balance of Payment (as % of service exports) in Mozambique in 2010?
Keep it short and to the point. -22.18. What is the difference between the Balance of Payment (as % of service exports) in Mauritius in 2009 and the Balance of Payment (as % of service exports) in Mozambique in 2010?
Your answer should be compact. -0.52. What is the difference between the Balance of Payment (as % of service exports) in Sub-Saharan Africa (developing only) in 2009 and the Balance of Payment (as % of service exports) in Cambodia in 2011?
Offer a terse response. 10.22. What is the difference between the Balance of Payment (as % of service exports) in Sub-Saharan Africa (developing only) in 2009 and the Balance of Payment (as % of service exports) in Mauritius in 2011?
Your answer should be very brief. -14.53. What is the difference between the Balance of Payment (as % of service exports) of Sub-Saharan Africa (developing only) in 2009 and the Balance of Payment (as % of service exports) of Mozambique in 2011?
Give a very brief answer. -6.84. What is the difference between the Balance of Payment (as % of service exports) of Cambodia in 2009 and the Balance of Payment (as % of service exports) of Mauritius in 2011?
Your answer should be compact. -23.54. What is the difference between the Balance of Payment (as % of service exports) in Cambodia in 2009 and the Balance of Payment (as % of service exports) in Mozambique in 2011?
Offer a terse response. -15.85. What is the difference between the Balance of Payment (as % of service exports) of Mauritius in 2009 and the Balance of Payment (as % of service exports) of Mozambique in 2011?
Ensure brevity in your answer.  5.81. What is the difference between the Balance of Payment (as % of service exports) in Sub-Saharan Africa (developing only) in 2009 and the Balance of Payment (as % of service exports) in Cambodia in 2012?
Your answer should be very brief. 9.87. What is the difference between the Balance of Payment (as % of service exports) in Sub-Saharan Africa (developing only) in 2009 and the Balance of Payment (as % of service exports) in Mauritius in 2012?
Provide a succinct answer. -18.81. What is the difference between the Balance of Payment (as % of service exports) of Sub-Saharan Africa (developing only) in 2009 and the Balance of Payment (as % of service exports) of Mozambique in 2012?
Provide a short and direct response. -15.42. What is the difference between the Balance of Payment (as % of service exports) in Cambodia in 2009 and the Balance of Payment (as % of service exports) in Mauritius in 2012?
Your response must be concise. -27.81. What is the difference between the Balance of Payment (as % of service exports) of Cambodia in 2009 and the Balance of Payment (as % of service exports) of Mozambique in 2012?
Provide a short and direct response. -24.42. What is the difference between the Balance of Payment (as % of service exports) of Mauritius in 2009 and the Balance of Payment (as % of service exports) of Mozambique in 2012?
Provide a short and direct response. -2.76. What is the difference between the Balance of Payment (as % of service exports) of Sub-Saharan Africa (developing only) in 2010 and the Balance of Payment (as % of service exports) of Cambodia in 2011?
Give a very brief answer. 9.85. What is the difference between the Balance of Payment (as % of service exports) of Sub-Saharan Africa (developing only) in 2010 and the Balance of Payment (as % of service exports) of Mauritius in 2011?
Ensure brevity in your answer.  -14.91. What is the difference between the Balance of Payment (as % of service exports) in Sub-Saharan Africa (developing only) in 2010 and the Balance of Payment (as % of service exports) in Mozambique in 2011?
Provide a succinct answer. -7.22. What is the difference between the Balance of Payment (as % of service exports) in Cambodia in 2010 and the Balance of Payment (as % of service exports) in Mauritius in 2011?
Keep it short and to the point. -25.34. What is the difference between the Balance of Payment (as % of service exports) of Cambodia in 2010 and the Balance of Payment (as % of service exports) of Mozambique in 2011?
Provide a short and direct response. -17.65. What is the difference between the Balance of Payment (as % of service exports) in Mauritius in 2010 and the Balance of Payment (as % of service exports) in Mozambique in 2011?
Your answer should be compact. 8.46. What is the difference between the Balance of Payment (as % of service exports) of Sub-Saharan Africa (developing only) in 2010 and the Balance of Payment (as % of service exports) of Cambodia in 2012?
Offer a very short reply. 9.5. What is the difference between the Balance of Payment (as % of service exports) in Sub-Saharan Africa (developing only) in 2010 and the Balance of Payment (as % of service exports) in Mauritius in 2012?
Ensure brevity in your answer.  -19.18. What is the difference between the Balance of Payment (as % of service exports) in Sub-Saharan Africa (developing only) in 2010 and the Balance of Payment (as % of service exports) in Mozambique in 2012?
Ensure brevity in your answer.  -15.79. What is the difference between the Balance of Payment (as % of service exports) of Cambodia in 2010 and the Balance of Payment (as % of service exports) of Mauritius in 2012?
Offer a very short reply. -29.61. What is the difference between the Balance of Payment (as % of service exports) in Cambodia in 2010 and the Balance of Payment (as % of service exports) in Mozambique in 2012?
Your answer should be compact. -26.22. What is the difference between the Balance of Payment (as % of service exports) in Mauritius in 2010 and the Balance of Payment (as % of service exports) in Mozambique in 2012?
Your answer should be very brief. -0.12. What is the difference between the Balance of Payment (as % of service exports) in Sub-Saharan Africa (developing only) in 2011 and the Balance of Payment (as % of service exports) in Cambodia in 2012?
Make the answer very short. 9.86. What is the difference between the Balance of Payment (as % of service exports) of Sub-Saharan Africa (developing only) in 2011 and the Balance of Payment (as % of service exports) of Mauritius in 2012?
Give a very brief answer. -18.82. What is the difference between the Balance of Payment (as % of service exports) in Sub-Saharan Africa (developing only) in 2011 and the Balance of Payment (as % of service exports) in Mozambique in 2012?
Offer a very short reply. -15.43. What is the difference between the Balance of Payment (as % of service exports) in Cambodia in 2011 and the Balance of Payment (as % of service exports) in Mauritius in 2012?
Your answer should be compact. -29.03. What is the difference between the Balance of Payment (as % of service exports) in Cambodia in 2011 and the Balance of Payment (as % of service exports) in Mozambique in 2012?
Provide a succinct answer. -25.64. What is the difference between the Balance of Payment (as % of service exports) in Mauritius in 2011 and the Balance of Payment (as % of service exports) in Mozambique in 2012?
Your answer should be very brief. -0.89. What is the average Balance of Payment (as % of service exports) of Sub-Saharan Africa (developing only) per year?
Provide a short and direct response. 15.35. What is the average Balance of Payment (as % of service exports) of Cambodia per year?
Keep it short and to the point. 7.29. What is the average Balance of Payment (as % of service exports) in Mauritius per year?
Keep it short and to the point. 25.07. What is the average Balance of Payment (as % of service exports) in Mozambique per year?
Your response must be concise. 24.27. In the year 2005, what is the difference between the Balance of Payment (as % of service exports) in Sub-Saharan Africa (developing only) and Balance of Payment (as % of service exports) in Cambodia?
Your response must be concise. 5.95. In the year 2005, what is the difference between the Balance of Payment (as % of service exports) in Sub-Saharan Africa (developing only) and Balance of Payment (as % of service exports) in Mauritius?
Give a very brief answer. -6.01. In the year 2005, what is the difference between the Balance of Payment (as % of service exports) of Sub-Saharan Africa (developing only) and Balance of Payment (as % of service exports) of Mozambique?
Ensure brevity in your answer.  -8.08. In the year 2005, what is the difference between the Balance of Payment (as % of service exports) in Cambodia and Balance of Payment (as % of service exports) in Mauritius?
Your answer should be very brief. -11.96. In the year 2005, what is the difference between the Balance of Payment (as % of service exports) of Cambodia and Balance of Payment (as % of service exports) of Mozambique?
Provide a short and direct response. -14.03. In the year 2005, what is the difference between the Balance of Payment (as % of service exports) in Mauritius and Balance of Payment (as % of service exports) in Mozambique?
Keep it short and to the point. -2.07. In the year 2006, what is the difference between the Balance of Payment (as % of service exports) of Sub-Saharan Africa (developing only) and Balance of Payment (as % of service exports) of Cambodia?
Provide a succinct answer. 5.32. In the year 2006, what is the difference between the Balance of Payment (as % of service exports) in Sub-Saharan Africa (developing only) and Balance of Payment (as % of service exports) in Mauritius?
Provide a short and direct response. -2.5. In the year 2006, what is the difference between the Balance of Payment (as % of service exports) of Sub-Saharan Africa (developing only) and Balance of Payment (as % of service exports) of Mozambique?
Your response must be concise. -8.39. In the year 2006, what is the difference between the Balance of Payment (as % of service exports) of Cambodia and Balance of Payment (as % of service exports) of Mauritius?
Make the answer very short. -7.82. In the year 2006, what is the difference between the Balance of Payment (as % of service exports) of Cambodia and Balance of Payment (as % of service exports) of Mozambique?
Your answer should be very brief. -13.71. In the year 2006, what is the difference between the Balance of Payment (as % of service exports) of Mauritius and Balance of Payment (as % of service exports) of Mozambique?
Your response must be concise. -5.89. In the year 2007, what is the difference between the Balance of Payment (as % of service exports) of Sub-Saharan Africa (developing only) and Balance of Payment (as % of service exports) of Cambodia?
Your answer should be very brief. 5.57. In the year 2007, what is the difference between the Balance of Payment (as % of service exports) in Sub-Saharan Africa (developing only) and Balance of Payment (as % of service exports) in Mauritius?
Keep it short and to the point. -2.84. In the year 2007, what is the difference between the Balance of Payment (as % of service exports) of Sub-Saharan Africa (developing only) and Balance of Payment (as % of service exports) of Mozambique?
Your answer should be very brief. -3.54. In the year 2007, what is the difference between the Balance of Payment (as % of service exports) of Cambodia and Balance of Payment (as % of service exports) of Mauritius?
Ensure brevity in your answer.  -8.41. In the year 2007, what is the difference between the Balance of Payment (as % of service exports) of Cambodia and Balance of Payment (as % of service exports) of Mozambique?
Ensure brevity in your answer.  -9.11. In the year 2007, what is the difference between the Balance of Payment (as % of service exports) in Mauritius and Balance of Payment (as % of service exports) in Mozambique?
Provide a short and direct response. -0.7. In the year 2008, what is the difference between the Balance of Payment (as % of service exports) of Sub-Saharan Africa (developing only) and Balance of Payment (as % of service exports) of Cambodia?
Provide a short and direct response. 7.47. In the year 2008, what is the difference between the Balance of Payment (as % of service exports) in Sub-Saharan Africa (developing only) and Balance of Payment (as % of service exports) in Mauritius?
Your answer should be very brief. -5.35. In the year 2008, what is the difference between the Balance of Payment (as % of service exports) in Sub-Saharan Africa (developing only) and Balance of Payment (as % of service exports) in Mozambique?
Make the answer very short. -4.59. In the year 2008, what is the difference between the Balance of Payment (as % of service exports) in Cambodia and Balance of Payment (as % of service exports) in Mauritius?
Ensure brevity in your answer.  -12.82. In the year 2008, what is the difference between the Balance of Payment (as % of service exports) of Cambodia and Balance of Payment (as % of service exports) of Mozambique?
Your answer should be compact. -12.07. In the year 2008, what is the difference between the Balance of Payment (as % of service exports) of Mauritius and Balance of Payment (as % of service exports) of Mozambique?
Provide a succinct answer. 0.75. In the year 2009, what is the difference between the Balance of Payment (as % of service exports) of Sub-Saharan Africa (developing only) and Balance of Payment (as % of service exports) of Cambodia?
Offer a terse response. 9.01. In the year 2009, what is the difference between the Balance of Payment (as % of service exports) in Sub-Saharan Africa (developing only) and Balance of Payment (as % of service exports) in Mauritius?
Your response must be concise. -12.65. In the year 2009, what is the difference between the Balance of Payment (as % of service exports) in Sub-Saharan Africa (developing only) and Balance of Payment (as % of service exports) in Mozambique?
Make the answer very short. -11.58. In the year 2009, what is the difference between the Balance of Payment (as % of service exports) of Cambodia and Balance of Payment (as % of service exports) of Mauritius?
Your response must be concise. -21.66. In the year 2009, what is the difference between the Balance of Payment (as % of service exports) in Cambodia and Balance of Payment (as % of service exports) in Mozambique?
Ensure brevity in your answer.  -20.58. In the year 2009, what is the difference between the Balance of Payment (as % of service exports) in Mauritius and Balance of Payment (as % of service exports) in Mozambique?
Give a very brief answer. 1.08. In the year 2010, what is the difference between the Balance of Payment (as % of service exports) of Sub-Saharan Africa (developing only) and Balance of Payment (as % of service exports) of Cambodia?
Provide a succinct answer. 10.43. In the year 2010, what is the difference between the Balance of Payment (as % of service exports) in Sub-Saharan Africa (developing only) and Balance of Payment (as % of service exports) in Mauritius?
Your response must be concise. -15.68. In the year 2010, what is the difference between the Balance of Payment (as % of service exports) in Sub-Saharan Africa (developing only) and Balance of Payment (as % of service exports) in Mozambique?
Offer a very short reply. -13.55. In the year 2010, what is the difference between the Balance of Payment (as % of service exports) in Cambodia and Balance of Payment (as % of service exports) in Mauritius?
Your response must be concise. -26.1. In the year 2010, what is the difference between the Balance of Payment (as % of service exports) in Cambodia and Balance of Payment (as % of service exports) in Mozambique?
Provide a short and direct response. -23.98. In the year 2010, what is the difference between the Balance of Payment (as % of service exports) of Mauritius and Balance of Payment (as % of service exports) of Mozambique?
Your response must be concise. 2.12. In the year 2011, what is the difference between the Balance of Payment (as % of service exports) of Sub-Saharan Africa (developing only) and Balance of Payment (as % of service exports) of Cambodia?
Your answer should be compact. 10.21. In the year 2011, what is the difference between the Balance of Payment (as % of service exports) of Sub-Saharan Africa (developing only) and Balance of Payment (as % of service exports) of Mauritius?
Offer a very short reply. -14.55. In the year 2011, what is the difference between the Balance of Payment (as % of service exports) of Sub-Saharan Africa (developing only) and Balance of Payment (as % of service exports) of Mozambique?
Provide a succinct answer. -6.86. In the year 2011, what is the difference between the Balance of Payment (as % of service exports) of Cambodia and Balance of Payment (as % of service exports) of Mauritius?
Offer a very short reply. -24.75. In the year 2011, what is the difference between the Balance of Payment (as % of service exports) in Cambodia and Balance of Payment (as % of service exports) in Mozambique?
Make the answer very short. -17.06. In the year 2011, what is the difference between the Balance of Payment (as % of service exports) of Mauritius and Balance of Payment (as % of service exports) of Mozambique?
Your answer should be very brief. 7.69. In the year 2012, what is the difference between the Balance of Payment (as % of service exports) in Sub-Saharan Africa (developing only) and Balance of Payment (as % of service exports) in Cambodia?
Your answer should be compact. 10.56. In the year 2012, what is the difference between the Balance of Payment (as % of service exports) of Sub-Saharan Africa (developing only) and Balance of Payment (as % of service exports) of Mauritius?
Make the answer very short. -18.12. In the year 2012, what is the difference between the Balance of Payment (as % of service exports) in Sub-Saharan Africa (developing only) and Balance of Payment (as % of service exports) in Mozambique?
Keep it short and to the point. -14.73. In the year 2012, what is the difference between the Balance of Payment (as % of service exports) in Cambodia and Balance of Payment (as % of service exports) in Mauritius?
Offer a very short reply. -28.68. In the year 2012, what is the difference between the Balance of Payment (as % of service exports) in Cambodia and Balance of Payment (as % of service exports) in Mozambique?
Give a very brief answer. -25.29. In the year 2012, what is the difference between the Balance of Payment (as % of service exports) in Mauritius and Balance of Payment (as % of service exports) in Mozambique?
Ensure brevity in your answer.  3.39. What is the ratio of the Balance of Payment (as % of service exports) of Sub-Saharan Africa (developing only) in 2005 to that in 2006?
Give a very brief answer. 1.02. What is the ratio of the Balance of Payment (as % of service exports) in Cambodia in 2005 to that in 2006?
Your response must be concise. 0.95. What is the ratio of the Balance of Payment (as % of service exports) of Mauritius in 2005 to that in 2006?
Your response must be concise. 1.26. What is the ratio of the Balance of Payment (as % of service exports) of Sub-Saharan Africa (developing only) in 2005 to that in 2007?
Your answer should be very brief. 0.81. What is the ratio of the Balance of Payment (as % of service exports) of Cambodia in 2005 to that in 2007?
Give a very brief answer. 0.67. What is the ratio of the Balance of Payment (as % of service exports) of Mauritius in 2005 to that in 2007?
Your answer should be compact. 1.02. What is the ratio of the Balance of Payment (as % of service exports) in Mozambique in 2005 to that in 2007?
Offer a very short reply. 1.09. What is the ratio of the Balance of Payment (as % of service exports) of Sub-Saharan Africa (developing only) in 2005 to that in 2008?
Offer a terse response. 0.77. What is the ratio of the Balance of Payment (as % of service exports) of Cambodia in 2005 to that in 2008?
Give a very brief answer. 0.75. What is the ratio of the Balance of Payment (as % of service exports) of Mauritius in 2005 to that in 2008?
Make the answer very short. 0.86. What is the ratio of the Balance of Payment (as % of service exports) of Sub-Saharan Africa (developing only) in 2005 to that in 2009?
Your answer should be compact. 0.75. What is the ratio of the Balance of Payment (as % of service exports) in Cambodia in 2005 to that in 2009?
Make the answer very short. 0.86. What is the ratio of the Balance of Payment (as % of service exports) of Mauritius in 2005 to that in 2009?
Make the answer very short. 0.63. What is the ratio of the Balance of Payment (as % of service exports) of Mozambique in 2005 to that in 2009?
Make the answer very short. 0.73. What is the ratio of the Balance of Payment (as % of service exports) of Sub-Saharan Africa (developing only) in 2005 to that in 2010?
Offer a very short reply. 0.77. What is the ratio of the Balance of Payment (as % of service exports) in Cambodia in 2005 to that in 2010?
Offer a terse response. 1.13. What is the ratio of the Balance of Payment (as % of service exports) of Mauritius in 2005 to that in 2010?
Give a very brief answer. 0.58. What is the ratio of the Balance of Payment (as % of service exports) in Mozambique in 2005 to that in 2010?
Ensure brevity in your answer.  0.69. What is the ratio of the Balance of Payment (as % of service exports) of Sub-Saharan Africa (developing only) in 2005 to that in 2011?
Ensure brevity in your answer.  0.75. What is the ratio of the Balance of Payment (as % of service exports) in Cambodia in 2005 to that in 2011?
Keep it short and to the point. 1.03. What is the ratio of the Balance of Payment (as % of service exports) in Mauritius in 2005 to that in 2011?
Provide a succinct answer. 0.59. What is the ratio of the Balance of Payment (as % of service exports) of Mozambique in 2005 to that in 2011?
Make the answer very short. 0.88. What is the ratio of the Balance of Payment (as % of service exports) of Sub-Saharan Africa (developing only) in 2005 to that in 2012?
Ensure brevity in your answer.  0.72. What is the ratio of the Balance of Payment (as % of service exports) in Cambodia in 2005 to that in 2012?
Your answer should be compact. 0.97. What is the ratio of the Balance of Payment (as % of service exports) in Mauritius in 2005 to that in 2012?
Make the answer very short. 0.52. What is the ratio of the Balance of Payment (as % of service exports) in Mozambique in 2005 to that in 2012?
Provide a succinct answer. 0.64. What is the ratio of the Balance of Payment (as % of service exports) in Sub-Saharan Africa (developing only) in 2006 to that in 2007?
Offer a terse response. 0.8. What is the ratio of the Balance of Payment (as % of service exports) of Cambodia in 2006 to that in 2007?
Your answer should be compact. 0.7. What is the ratio of the Balance of Payment (as % of service exports) in Mauritius in 2006 to that in 2007?
Offer a terse response. 0.81. What is the ratio of the Balance of Payment (as % of service exports) in Mozambique in 2006 to that in 2007?
Your answer should be very brief. 1.09. What is the ratio of the Balance of Payment (as % of service exports) of Sub-Saharan Africa (developing only) in 2006 to that in 2008?
Offer a very short reply. 0.75. What is the ratio of the Balance of Payment (as % of service exports) of Cambodia in 2006 to that in 2008?
Give a very brief answer. 0.79. What is the ratio of the Balance of Payment (as % of service exports) of Mauritius in 2006 to that in 2008?
Make the answer very short. 0.68. What is the ratio of the Balance of Payment (as % of service exports) in Sub-Saharan Africa (developing only) in 2006 to that in 2009?
Your response must be concise. 0.74. What is the ratio of the Balance of Payment (as % of service exports) in Cambodia in 2006 to that in 2009?
Give a very brief answer. 0.91. What is the ratio of the Balance of Payment (as % of service exports) of Mauritius in 2006 to that in 2009?
Give a very brief answer. 0.5. What is the ratio of the Balance of Payment (as % of service exports) of Mozambique in 2006 to that in 2009?
Ensure brevity in your answer.  0.73. What is the ratio of the Balance of Payment (as % of service exports) in Sub-Saharan Africa (developing only) in 2006 to that in 2010?
Your response must be concise. 0.75. What is the ratio of the Balance of Payment (as % of service exports) of Cambodia in 2006 to that in 2010?
Offer a terse response. 1.19. What is the ratio of the Balance of Payment (as % of service exports) of Mauritius in 2006 to that in 2010?
Make the answer very short. 0.46. What is the ratio of the Balance of Payment (as % of service exports) in Mozambique in 2006 to that in 2010?
Your answer should be compact. 0.69. What is the ratio of the Balance of Payment (as % of service exports) in Sub-Saharan Africa (developing only) in 2006 to that in 2011?
Your answer should be compact. 0.74. What is the ratio of the Balance of Payment (as % of service exports) in Cambodia in 2006 to that in 2011?
Your response must be concise. 1.08. What is the ratio of the Balance of Payment (as % of service exports) of Mauritius in 2006 to that in 2011?
Your answer should be compact. 0.47. What is the ratio of the Balance of Payment (as % of service exports) in Mozambique in 2006 to that in 2011?
Make the answer very short. 0.88. What is the ratio of the Balance of Payment (as % of service exports) of Sub-Saharan Africa (developing only) in 2006 to that in 2012?
Offer a very short reply. 0.71. What is the ratio of the Balance of Payment (as % of service exports) in Cambodia in 2006 to that in 2012?
Ensure brevity in your answer.  1.02. What is the ratio of the Balance of Payment (as % of service exports) in Mauritius in 2006 to that in 2012?
Provide a succinct answer. 0.42. What is the ratio of the Balance of Payment (as % of service exports) of Mozambique in 2006 to that in 2012?
Give a very brief answer. 0.64. What is the ratio of the Balance of Payment (as % of service exports) of Sub-Saharan Africa (developing only) in 2007 to that in 2008?
Provide a short and direct response. 0.95. What is the ratio of the Balance of Payment (as % of service exports) of Cambodia in 2007 to that in 2008?
Your response must be concise. 1.12. What is the ratio of the Balance of Payment (as % of service exports) in Mauritius in 2007 to that in 2008?
Provide a short and direct response. 0.84. What is the ratio of the Balance of Payment (as % of service exports) in Mozambique in 2007 to that in 2008?
Give a very brief answer. 0.91. What is the ratio of the Balance of Payment (as % of service exports) in Sub-Saharan Africa (developing only) in 2007 to that in 2009?
Provide a short and direct response. 0.92. What is the ratio of the Balance of Payment (as % of service exports) in Cambodia in 2007 to that in 2009?
Your response must be concise. 1.29. What is the ratio of the Balance of Payment (as % of service exports) in Mauritius in 2007 to that in 2009?
Offer a terse response. 0.62. What is the ratio of the Balance of Payment (as % of service exports) of Mozambique in 2007 to that in 2009?
Offer a very short reply. 0.67. What is the ratio of the Balance of Payment (as % of service exports) of Sub-Saharan Africa (developing only) in 2007 to that in 2010?
Offer a terse response. 0.95. What is the ratio of the Balance of Payment (as % of service exports) in Cambodia in 2007 to that in 2010?
Provide a short and direct response. 1.69. What is the ratio of the Balance of Payment (as % of service exports) of Mauritius in 2007 to that in 2010?
Make the answer very short. 0.57. What is the ratio of the Balance of Payment (as % of service exports) in Mozambique in 2007 to that in 2010?
Your response must be concise. 0.63. What is the ratio of the Balance of Payment (as % of service exports) in Sub-Saharan Africa (developing only) in 2007 to that in 2011?
Ensure brevity in your answer.  0.93. What is the ratio of the Balance of Payment (as % of service exports) in Cambodia in 2007 to that in 2011?
Your answer should be very brief. 1.54. What is the ratio of the Balance of Payment (as % of service exports) of Mauritius in 2007 to that in 2011?
Provide a short and direct response. 0.58. What is the ratio of the Balance of Payment (as % of service exports) in Mozambique in 2007 to that in 2011?
Keep it short and to the point. 0.81. What is the ratio of the Balance of Payment (as % of service exports) of Sub-Saharan Africa (developing only) in 2007 to that in 2012?
Your response must be concise. 0.89. What is the ratio of the Balance of Payment (as % of service exports) of Cambodia in 2007 to that in 2012?
Give a very brief answer. 1.46. What is the ratio of the Balance of Payment (as % of service exports) in Mauritius in 2007 to that in 2012?
Your answer should be very brief. 0.51. What is the ratio of the Balance of Payment (as % of service exports) of Mozambique in 2007 to that in 2012?
Offer a terse response. 0.59. What is the ratio of the Balance of Payment (as % of service exports) of Sub-Saharan Africa (developing only) in 2008 to that in 2009?
Ensure brevity in your answer.  0.98. What is the ratio of the Balance of Payment (as % of service exports) of Cambodia in 2008 to that in 2009?
Your answer should be compact. 1.15. What is the ratio of the Balance of Payment (as % of service exports) in Mauritius in 2008 to that in 2009?
Provide a succinct answer. 0.74. What is the ratio of the Balance of Payment (as % of service exports) of Mozambique in 2008 to that in 2009?
Ensure brevity in your answer.  0.74. What is the ratio of the Balance of Payment (as % of service exports) in Cambodia in 2008 to that in 2010?
Your response must be concise. 1.51. What is the ratio of the Balance of Payment (as % of service exports) in Mauritius in 2008 to that in 2010?
Provide a succinct answer. 0.68. What is the ratio of the Balance of Payment (as % of service exports) in Mozambique in 2008 to that in 2010?
Your answer should be compact. 0.7. What is the ratio of the Balance of Payment (as % of service exports) of Sub-Saharan Africa (developing only) in 2008 to that in 2011?
Your answer should be very brief. 0.98. What is the ratio of the Balance of Payment (as % of service exports) of Cambodia in 2008 to that in 2011?
Your answer should be very brief. 1.37. What is the ratio of the Balance of Payment (as % of service exports) of Mauritius in 2008 to that in 2011?
Your response must be concise. 0.69. What is the ratio of the Balance of Payment (as % of service exports) in Mozambique in 2008 to that in 2011?
Your answer should be very brief. 0.89. What is the ratio of the Balance of Payment (as % of service exports) in Sub-Saharan Africa (developing only) in 2008 to that in 2012?
Offer a very short reply. 0.94. What is the ratio of the Balance of Payment (as % of service exports) in Cambodia in 2008 to that in 2012?
Keep it short and to the point. 1.3. What is the ratio of the Balance of Payment (as % of service exports) of Mauritius in 2008 to that in 2012?
Your response must be concise. 0.61. What is the ratio of the Balance of Payment (as % of service exports) in Mozambique in 2008 to that in 2012?
Your response must be concise. 0.65. What is the ratio of the Balance of Payment (as % of service exports) in Sub-Saharan Africa (developing only) in 2009 to that in 2010?
Make the answer very short. 1.02. What is the ratio of the Balance of Payment (as % of service exports) of Cambodia in 2009 to that in 2010?
Keep it short and to the point. 1.31. What is the ratio of the Balance of Payment (as % of service exports) in Mauritius in 2009 to that in 2010?
Your answer should be very brief. 0.92. What is the ratio of the Balance of Payment (as % of service exports) of Mozambique in 2009 to that in 2010?
Give a very brief answer. 0.95. What is the ratio of the Balance of Payment (as % of service exports) in Cambodia in 2009 to that in 2011?
Ensure brevity in your answer.  1.19. What is the ratio of the Balance of Payment (as % of service exports) of Mauritius in 2009 to that in 2011?
Ensure brevity in your answer.  0.94. What is the ratio of the Balance of Payment (as % of service exports) of Mozambique in 2009 to that in 2011?
Provide a succinct answer. 1.2. What is the ratio of the Balance of Payment (as % of service exports) in Sub-Saharan Africa (developing only) in 2009 to that in 2012?
Provide a short and direct response. 0.96. What is the ratio of the Balance of Payment (as % of service exports) in Cambodia in 2009 to that in 2012?
Provide a short and direct response. 1.13. What is the ratio of the Balance of Payment (as % of service exports) in Mauritius in 2009 to that in 2012?
Keep it short and to the point. 0.83. What is the ratio of the Balance of Payment (as % of service exports) in Mozambique in 2009 to that in 2012?
Your answer should be very brief. 0.88. What is the ratio of the Balance of Payment (as % of service exports) in Sub-Saharan Africa (developing only) in 2010 to that in 2011?
Offer a terse response. 0.98. What is the ratio of the Balance of Payment (as % of service exports) in Cambodia in 2010 to that in 2011?
Offer a very short reply. 0.91. What is the ratio of the Balance of Payment (as % of service exports) of Mauritius in 2010 to that in 2011?
Give a very brief answer. 1.02. What is the ratio of the Balance of Payment (as % of service exports) of Mozambique in 2010 to that in 2011?
Offer a very short reply. 1.27. What is the ratio of the Balance of Payment (as % of service exports) in Sub-Saharan Africa (developing only) in 2010 to that in 2012?
Offer a very short reply. 0.94. What is the ratio of the Balance of Payment (as % of service exports) of Cambodia in 2010 to that in 2012?
Ensure brevity in your answer.  0.86. What is the ratio of the Balance of Payment (as % of service exports) of Mauritius in 2010 to that in 2012?
Give a very brief answer. 0.9. What is the ratio of the Balance of Payment (as % of service exports) of Mozambique in 2010 to that in 2012?
Your answer should be very brief. 0.93. What is the ratio of the Balance of Payment (as % of service exports) of Sub-Saharan Africa (developing only) in 2011 to that in 2012?
Your response must be concise. 0.96. What is the ratio of the Balance of Payment (as % of service exports) of Cambodia in 2011 to that in 2012?
Your answer should be very brief. 0.95. What is the ratio of the Balance of Payment (as % of service exports) in Mauritius in 2011 to that in 2012?
Ensure brevity in your answer.  0.88. What is the ratio of the Balance of Payment (as % of service exports) in Mozambique in 2011 to that in 2012?
Your response must be concise. 0.73. What is the difference between the highest and the second highest Balance of Payment (as % of service exports) of Sub-Saharan Africa (developing only)?
Your response must be concise. 0.69. What is the difference between the highest and the second highest Balance of Payment (as % of service exports) of Cambodia?
Offer a very short reply. 1.05. What is the difference between the highest and the second highest Balance of Payment (as % of service exports) in Mauritius?
Ensure brevity in your answer.  3.5. What is the difference between the highest and the second highest Balance of Payment (as % of service exports) of Mozambique?
Your response must be concise. 2.24. What is the difference between the highest and the lowest Balance of Payment (as % of service exports) of Sub-Saharan Africa (developing only)?
Provide a succinct answer. 5.08. What is the difference between the highest and the lowest Balance of Payment (as % of service exports) of Cambodia?
Your response must be concise. 3.99. What is the difference between the highest and the lowest Balance of Payment (as % of service exports) of Mauritius?
Make the answer very short. 20.7. What is the difference between the highest and the lowest Balance of Payment (as % of service exports) of Mozambique?
Provide a short and direct response. 13.13. 